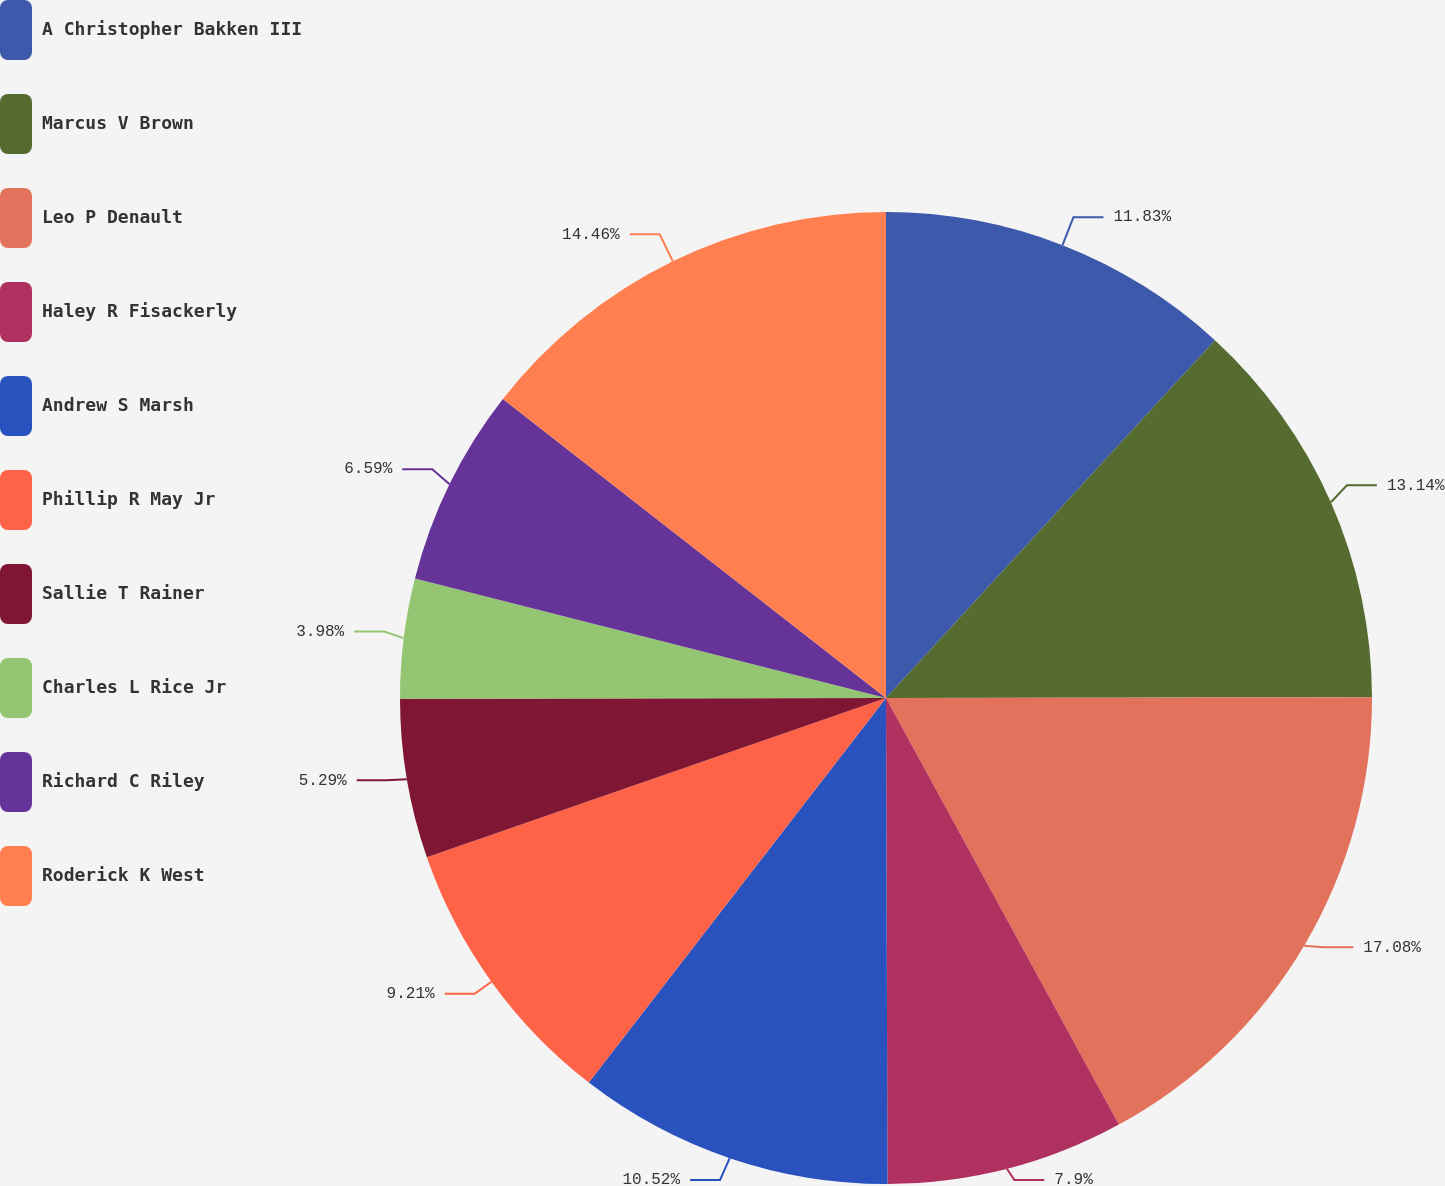Convert chart to OTSL. <chart><loc_0><loc_0><loc_500><loc_500><pie_chart><fcel>A Christopher Bakken III<fcel>Marcus V Brown<fcel>Leo P Denault<fcel>Haley R Fisackerly<fcel>Andrew S Marsh<fcel>Phillip R May Jr<fcel>Sallie T Rainer<fcel>Charles L Rice Jr<fcel>Richard C Riley<fcel>Roderick K West<nl><fcel>11.83%<fcel>13.14%<fcel>17.07%<fcel>7.9%<fcel>10.52%<fcel>9.21%<fcel>5.29%<fcel>3.98%<fcel>6.59%<fcel>14.45%<nl></chart> 